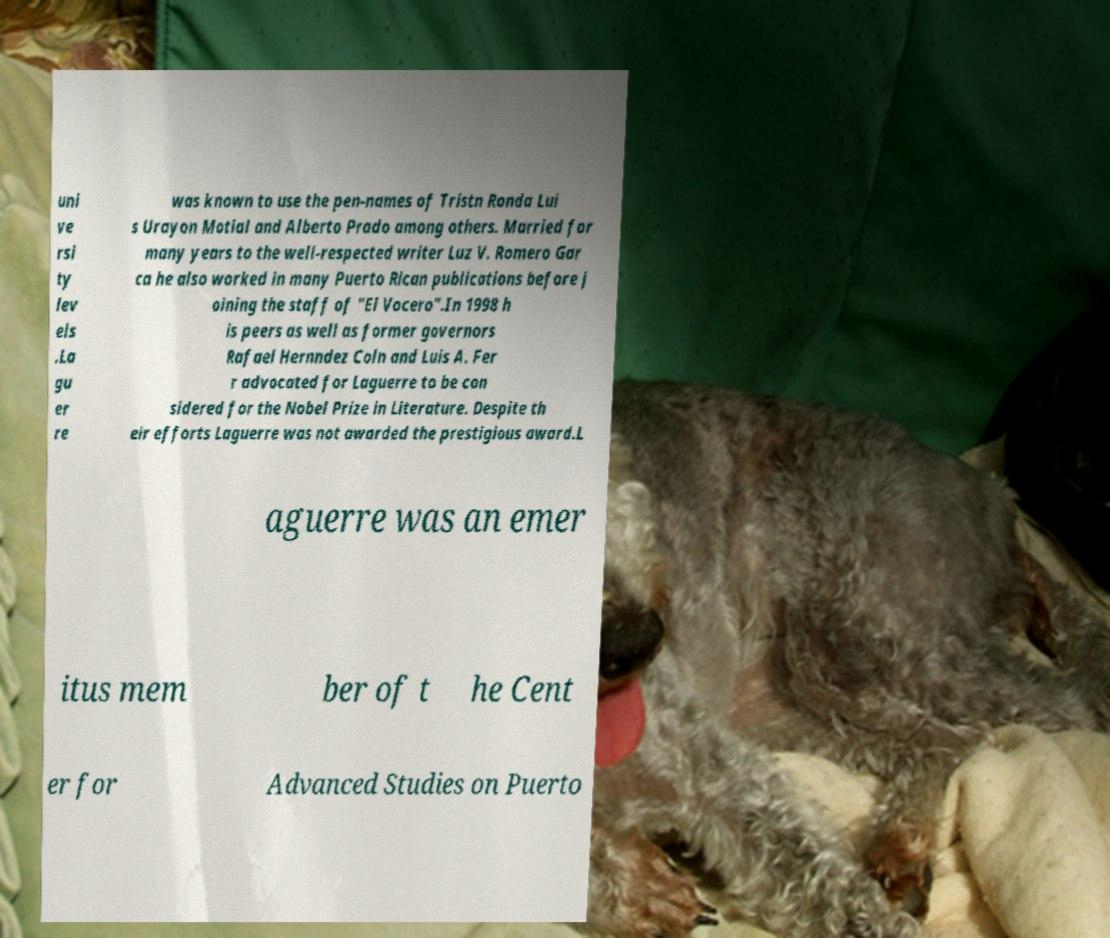There's text embedded in this image that I need extracted. Can you transcribe it verbatim? uni ve rsi ty lev els .La gu er re was known to use the pen-names of Tristn Ronda Lui s Urayon Motial and Alberto Prado among others. Married for many years to the well-respected writer Luz V. Romero Gar ca he also worked in many Puerto Rican publications before j oining the staff of "El Vocero".In 1998 h is peers as well as former governors Rafael Hernndez Coln and Luis A. Fer r advocated for Laguerre to be con sidered for the Nobel Prize in Literature. Despite th eir efforts Laguerre was not awarded the prestigious award.L aguerre was an emer itus mem ber of t he Cent er for Advanced Studies on Puerto 